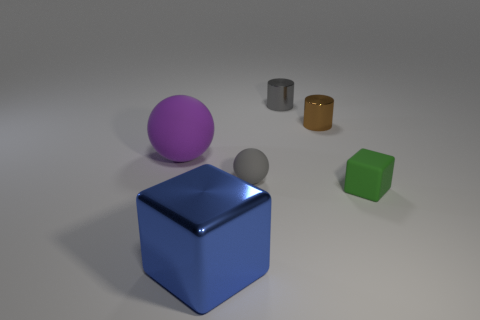Are there any other things that have the same size as the purple rubber sphere?
Provide a succinct answer. Yes. Do the gray thing that is in front of the brown metallic cylinder and the shiny thing that is in front of the small green block have the same shape?
Offer a very short reply. No. What number of things are red rubber objects or cubes behind the blue object?
Offer a terse response. 1. The tiny shiny object that is the same color as the tiny rubber sphere is what shape?
Your answer should be very brief. Cylinder. What number of gray matte spheres are the same size as the brown shiny cylinder?
Your answer should be very brief. 1. What number of green objects are matte objects or small shiny balls?
Offer a terse response. 1. What shape is the small gray object that is left of the small metallic cylinder that is left of the tiny brown object?
Your response must be concise. Sphere. There is another object that is the same size as the purple object; what shape is it?
Provide a succinct answer. Cube. Is there a big metallic thing of the same color as the metallic cube?
Provide a succinct answer. No. Is the number of small gray things that are behind the small gray rubber object the same as the number of rubber blocks that are in front of the large purple ball?
Give a very brief answer. Yes. 